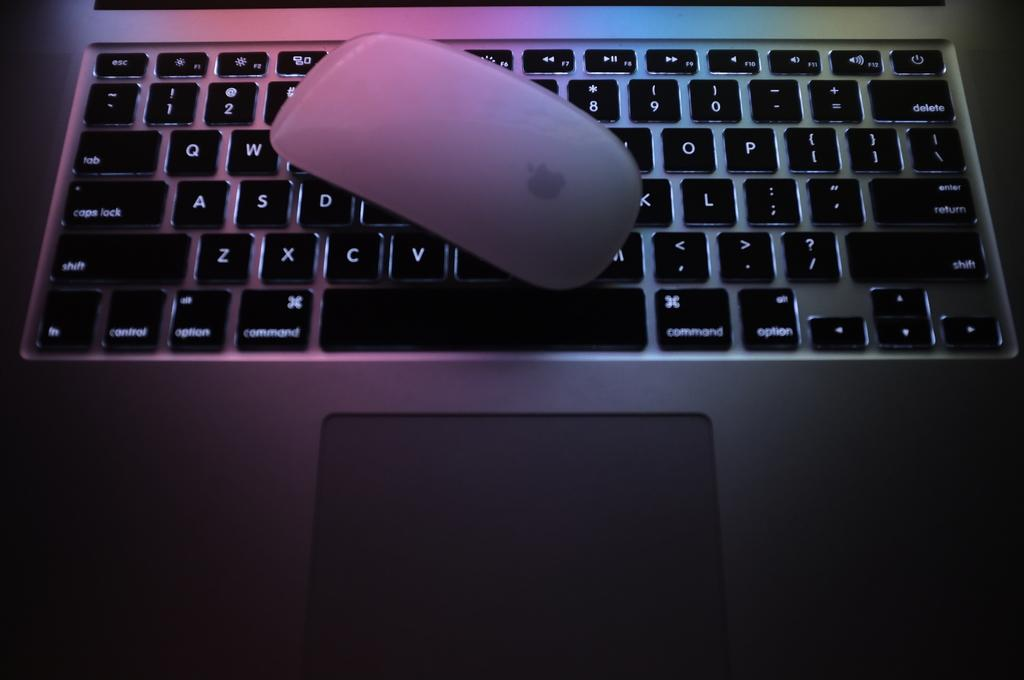Provide a one-sentence caption for the provided image. An apple mouse is covering up part of the keyboard, but the command key is still visible. 